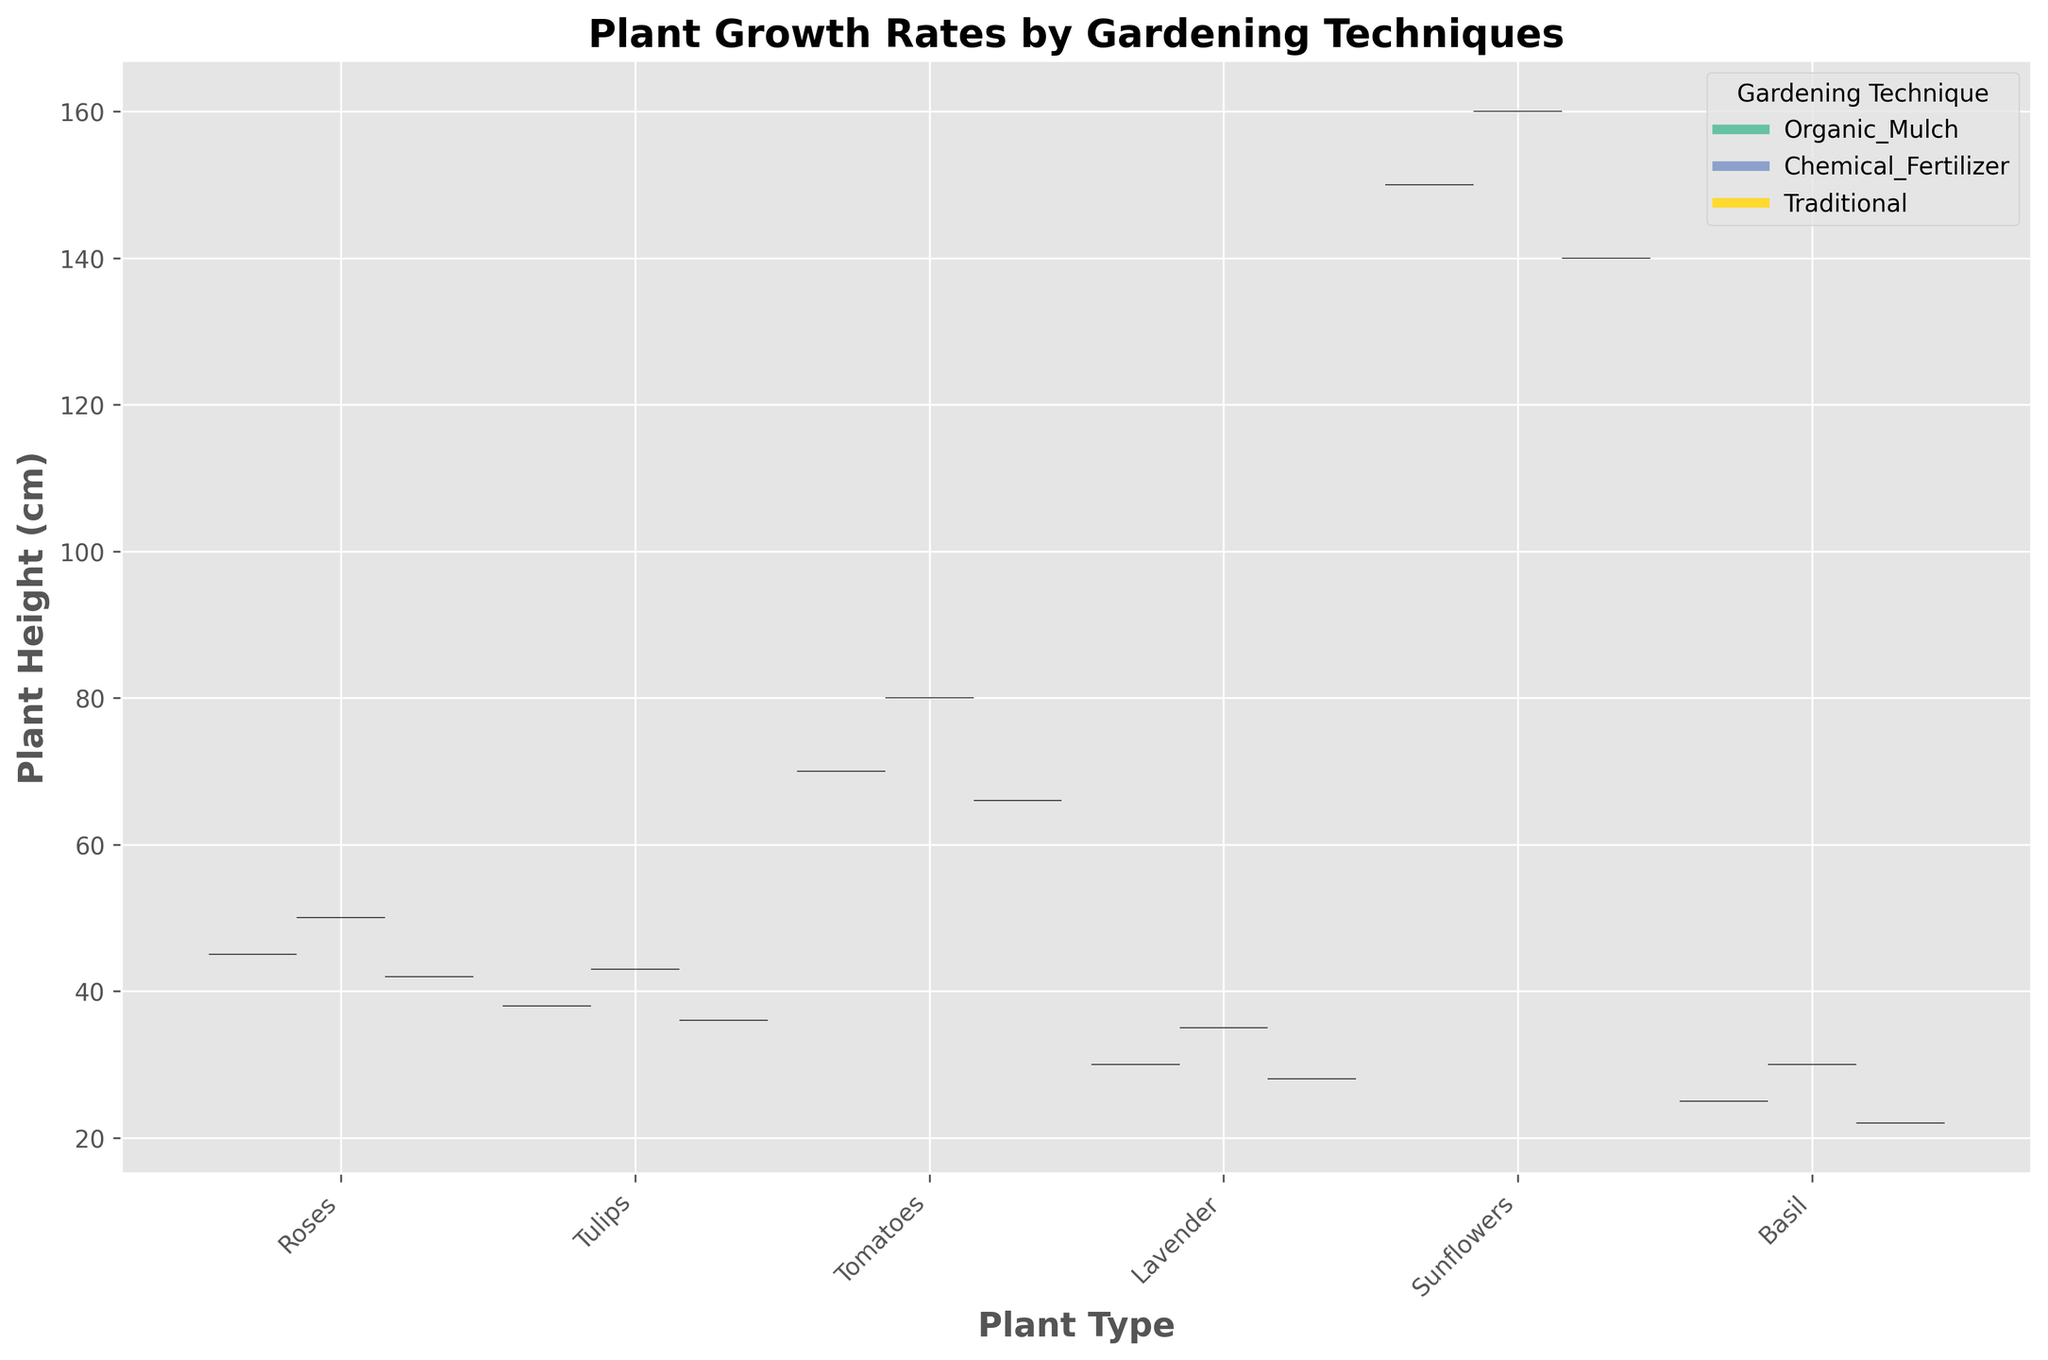What is the title of the plot? The title of the plot is displayed at the top and provides a summary of what the chart represents. The title here indicates the comparison being made.
Answer: Plant Growth Rates by Gardening Techniques What are the labels on the x-axis and y-axis? The x-axis label shows the categories of plant types being compared, while the y-axis label indicates the measurement being observed.
Answer: x-axis: Plant Type, y-axis: Plant Height (cm) Which gardening technique appears to result in the tallest sunflowers? By comparing the heights of the violin plots for Sunflowers, the technique with the highest peak represents the tallest plants.
Answer: Chemical Fertilizer Which plant type shows the most varied growth under Organic Mulch? Look at the width and spread of the violin plots for each plant type under Organic Mulch. The plot with the greatest spread indicates the most variation.
Answer: Sunflowers How much taller are tomatoes grown with Chemical Fertilizer compared to Traditional techniques? Identify the central tendency of the tomato heights for Chemical Fertilizer and Traditional techniques and calculate the difference.
Answer: 14 cm Which plant type benefits the least from Chemical Fertilizer compared to other techniques? Compare the heights of the plant types under Chemical Fertilizer against Organic Mulch and Traditional techniques to see which has the smallest increase.
Answer: Basil For which plant type is the difference between Organic Mulch and Traditional techniques the smallest? Calculate the height difference for each plant type between Organic Mulch and Traditional techniques, and identify the smallest value.
Answer: Lavender Is there a plant type where Traditional techniques result in higher growth than Organic Mulch? Examine the violin plots to identify any plant types where the Traditional technique plot has a higher peak than the Organic Mulch.
Answer: No Which plant shows the most consistent growth regardless of the gardening technique? Look for the plant type whose violin plots have the least spread and are closest in height across all techniques.
Answer: Lavender 